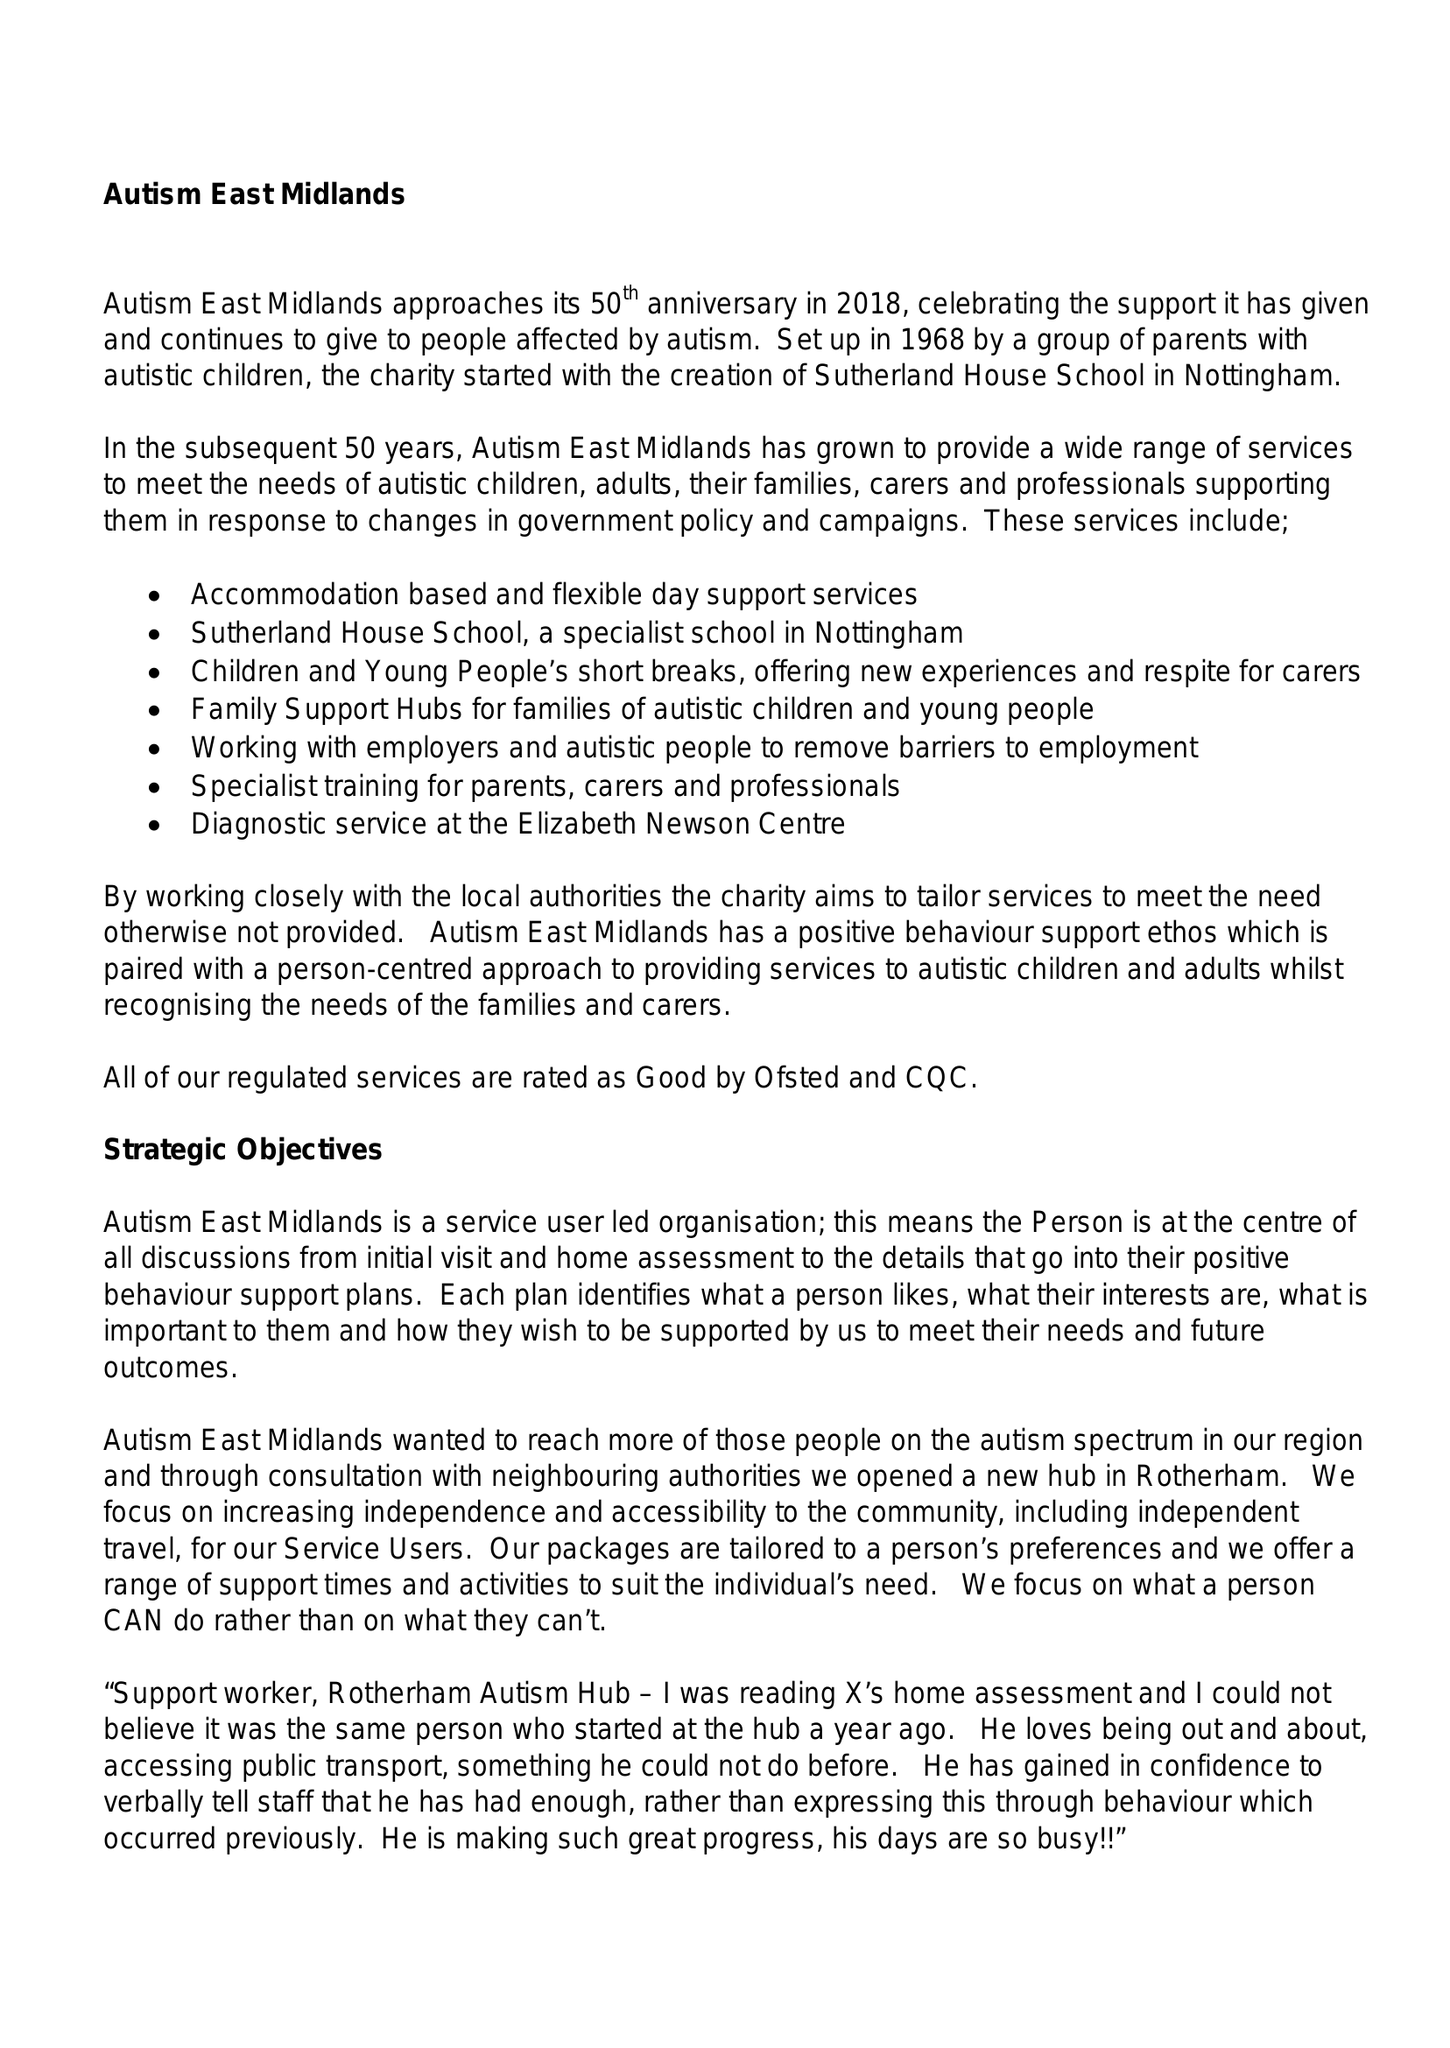What is the value for the address__postcode?
Answer the question using a single word or phrase. S80 4AJ 